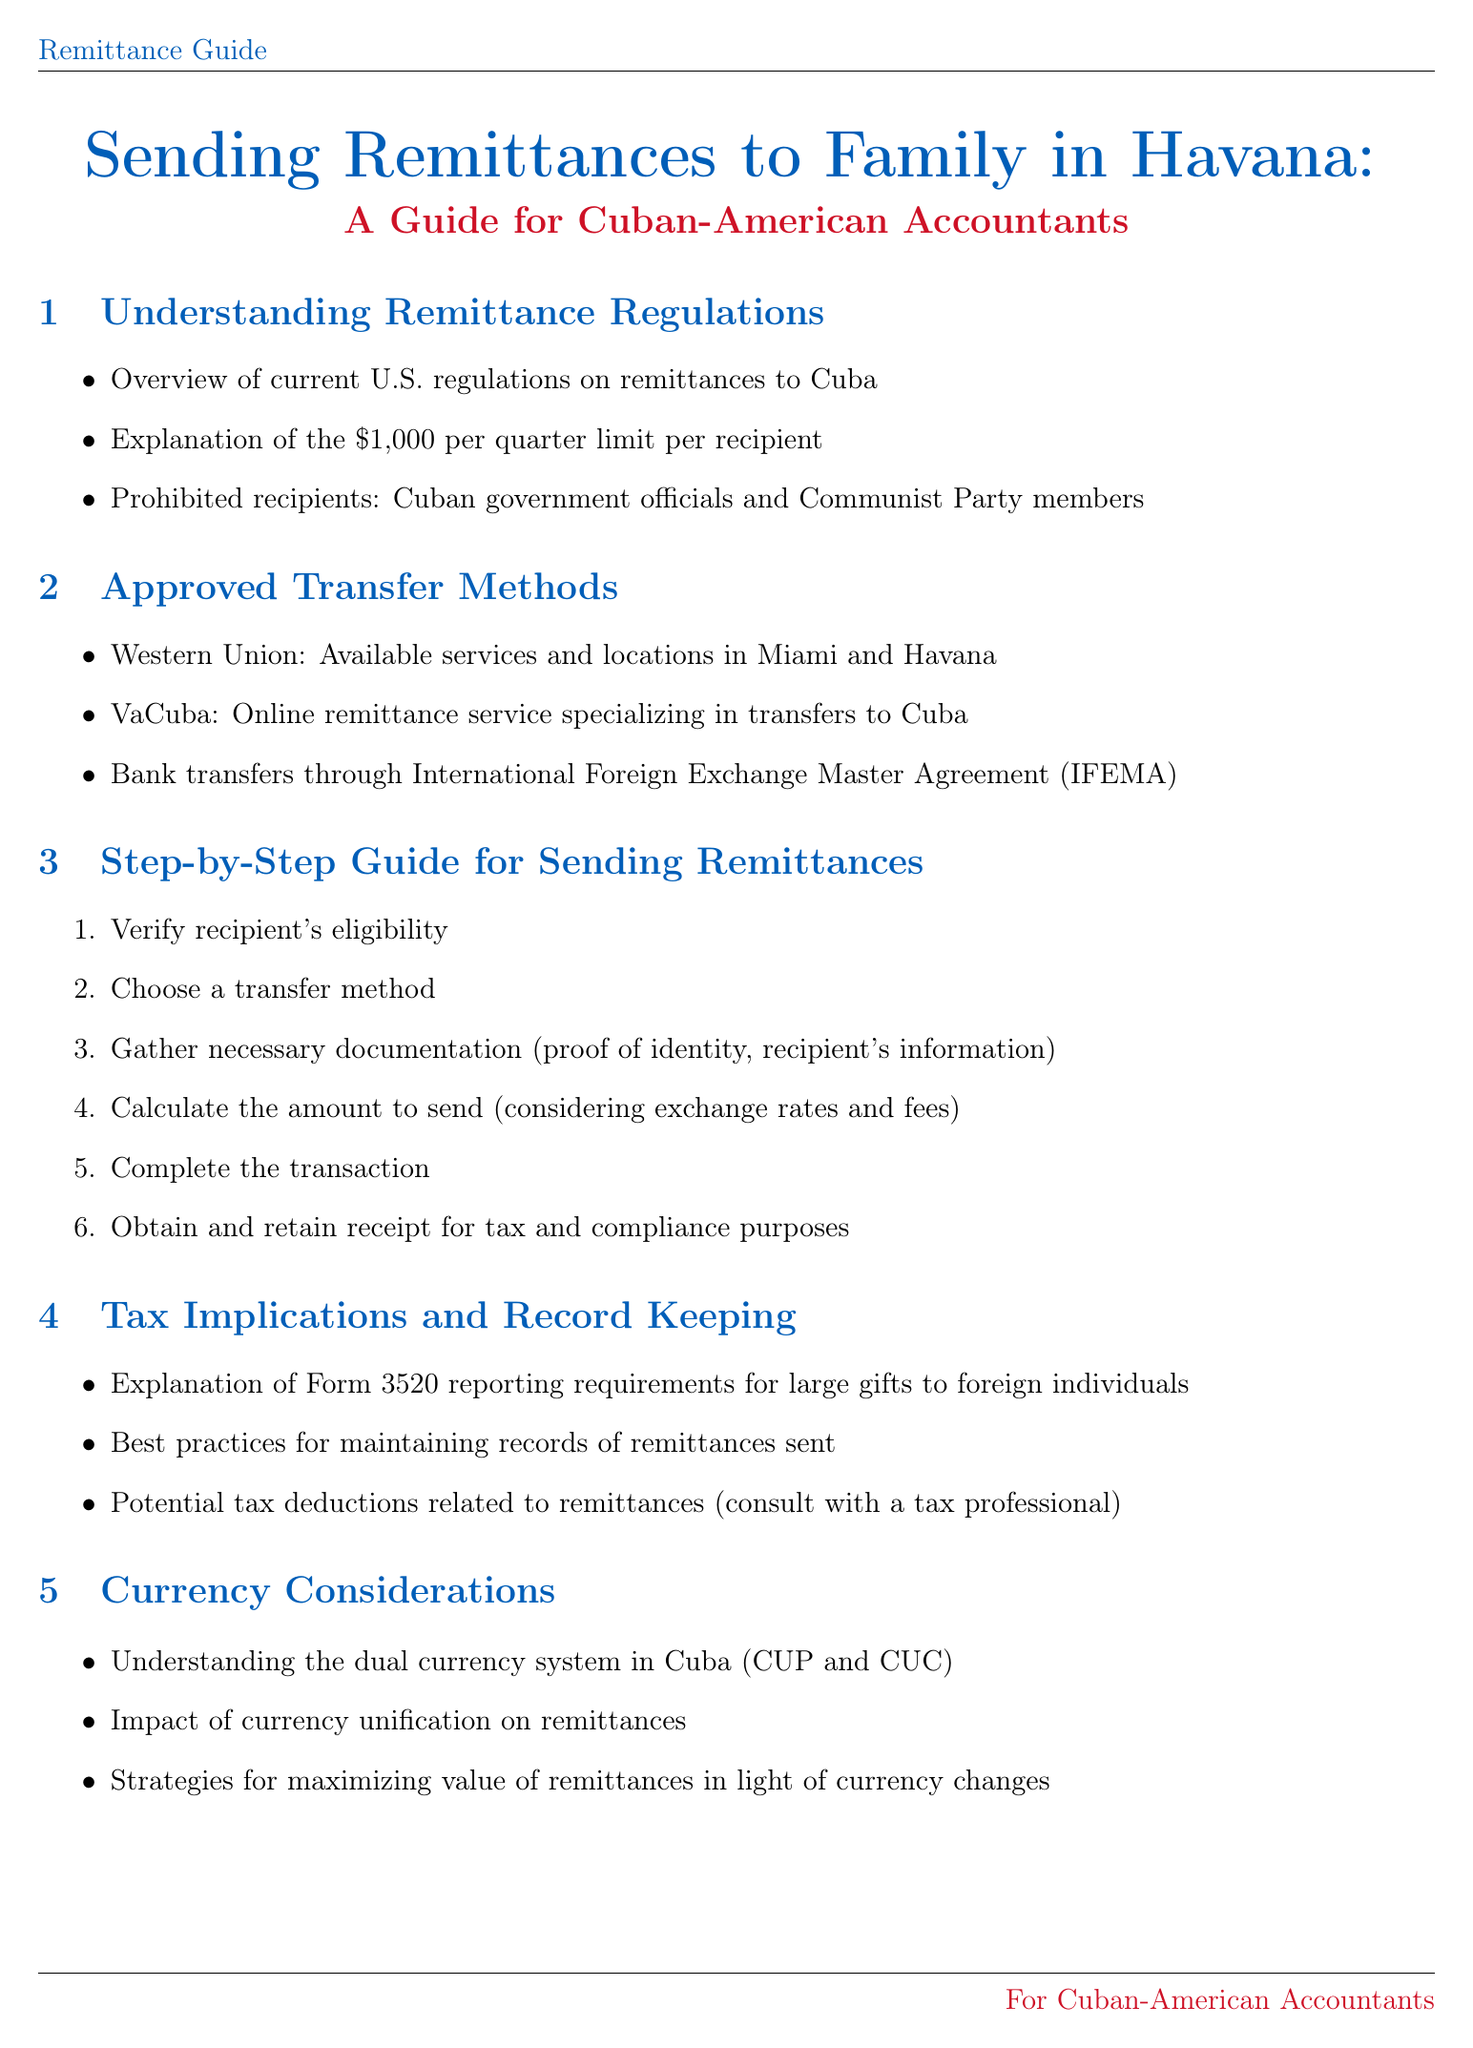What is the remittance limit per recipient? The document states the limit on remittances to Cuba is $1,000 per quarter per recipient.
Answer: $1,000 per quarter Which online service specializes in transfers to Cuba? The document lists VaCuba as an online remittance service specializing in transfers to Cuba.
Answer: VaCuba What are prohibited recipients for remittances? The document mentions that Cuban government officials and Communist Party members are prohibited recipients.
Answer: Cuban government officials and Communist Party members What is the first step in sending remittances? The step-by-step guide in the document indicates that the first step is to verify the recipient's eligibility.
Answer: Verify recipient's eligibility What form is required for reporting large gifts to foreign individuals? The document specifies that Form 3520 is required for reporting large gifts to foreign individuals.
Answer: Form 3520 What dual currency system is mentioned in the guide? The document refers to the dual currency system in Cuba as CUP and CUC.
Answer: CUP and CUC Which U.S. office provides information about remittances? The document states the U.S. Department of the Treasury's Office of Foreign Assets Control (OFAC) website is a resource.
Answer: OFAC What should be kept for tax and compliance purposes? The document advises to obtain and retain a receipt for tax and compliance purposes.
Answer: Receipt 